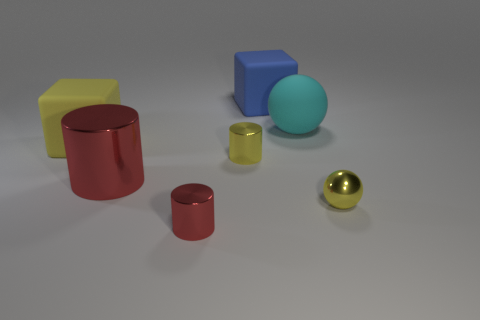There is a shiny cylinder that is the same color as the big metallic object; what is its size?
Offer a very short reply. Small. Are there any small metallic cylinders that have the same color as the large metal cylinder?
Keep it short and to the point. Yes. The object that is the same color as the large metallic cylinder is what shape?
Ensure brevity in your answer.  Cylinder. Are there an equal number of big cyan rubber spheres that are to the left of the large cylinder and green matte cylinders?
Keep it short and to the point. Yes. What is the color of the other object that is the same shape as the big cyan object?
Your answer should be compact. Yellow. Are the cube in front of the blue matte thing and the large ball made of the same material?
Provide a short and direct response. Yes. What number of small objects are green cubes or yellow cylinders?
Offer a very short reply. 1. The yellow metal cylinder has what size?
Offer a terse response. Small. Is the size of the yellow metal cylinder the same as the red cylinder that is in front of the tiny yellow sphere?
Your answer should be very brief. Yes. How many red things are either metallic spheres or big metal spheres?
Your answer should be compact. 0. 